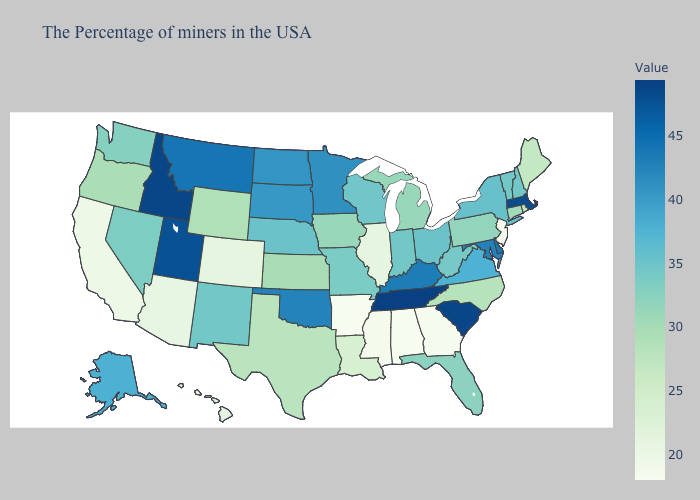Among the states that border Idaho , does Montana have the lowest value?
Keep it brief. No. Among the states that border Rhode Island , does Massachusetts have the lowest value?
Write a very short answer. No. Does Rhode Island have a lower value than Colorado?
Quick response, please. No. Which states hav the highest value in the South?
Concise answer only. Tennessee. Does Illinois have a lower value than Oklahoma?
Answer briefly. Yes. Is the legend a continuous bar?
Answer briefly. Yes. 